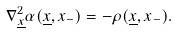<formula> <loc_0><loc_0><loc_500><loc_500>\nabla _ { \underline { x } } ^ { 2 } \alpha ( \underline { x } , x _ { - } ) = - \rho ( \underline { x } , x _ { - } ) .</formula> 